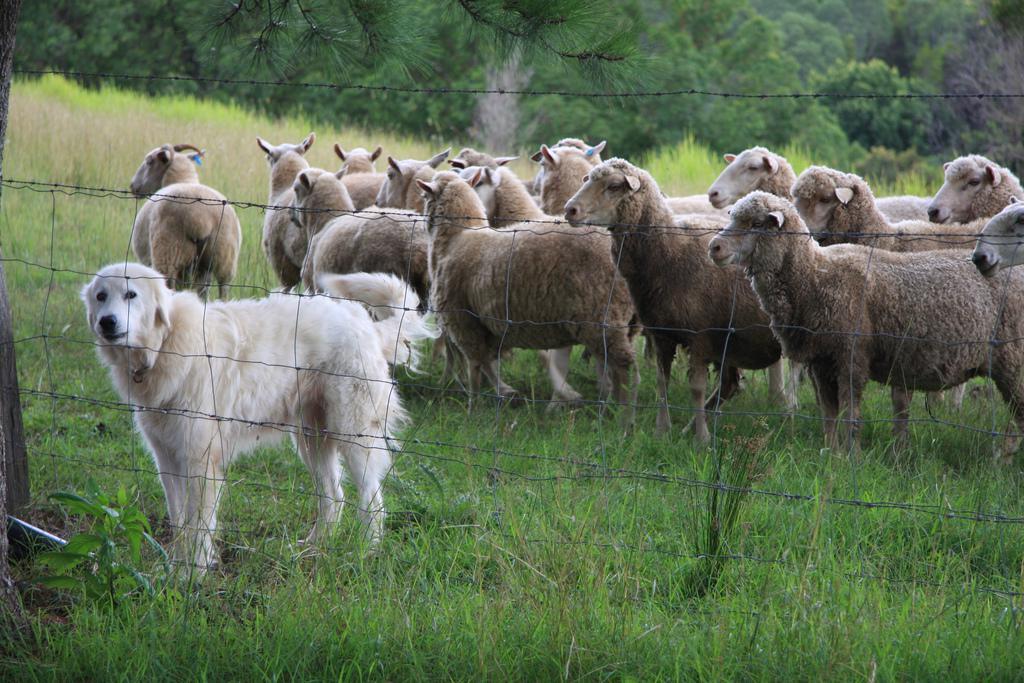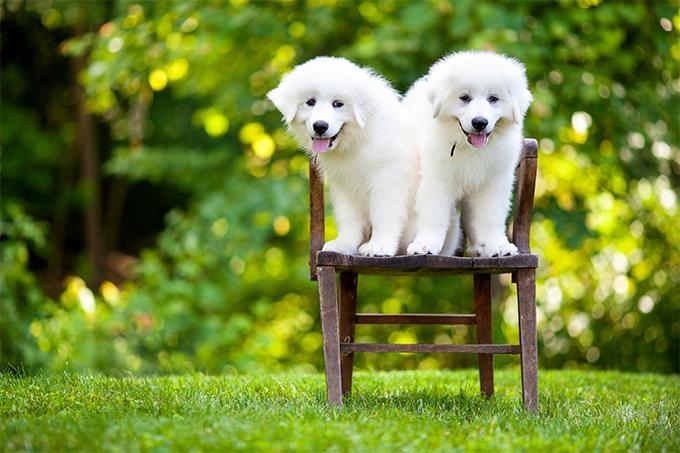The first image is the image on the left, the second image is the image on the right. Analyze the images presented: Is the assertion "The white dog is lying in the grass in the image on the left." valid? Answer yes or no. No. The first image is the image on the left, the second image is the image on the right. Considering the images on both sides, is "An image shows a white dog with a herd of livestock." valid? Answer yes or no. Yes. 